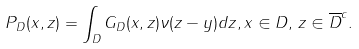<formula> <loc_0><loc_0><loc_500><loc_500>P _ { D } ( x , z ) = \int _ { D } G _ { D } ( x , z ) \nu ( z - y ) d z , x \in D , \, z \in \overline { D } ^ { c } .</formula> 